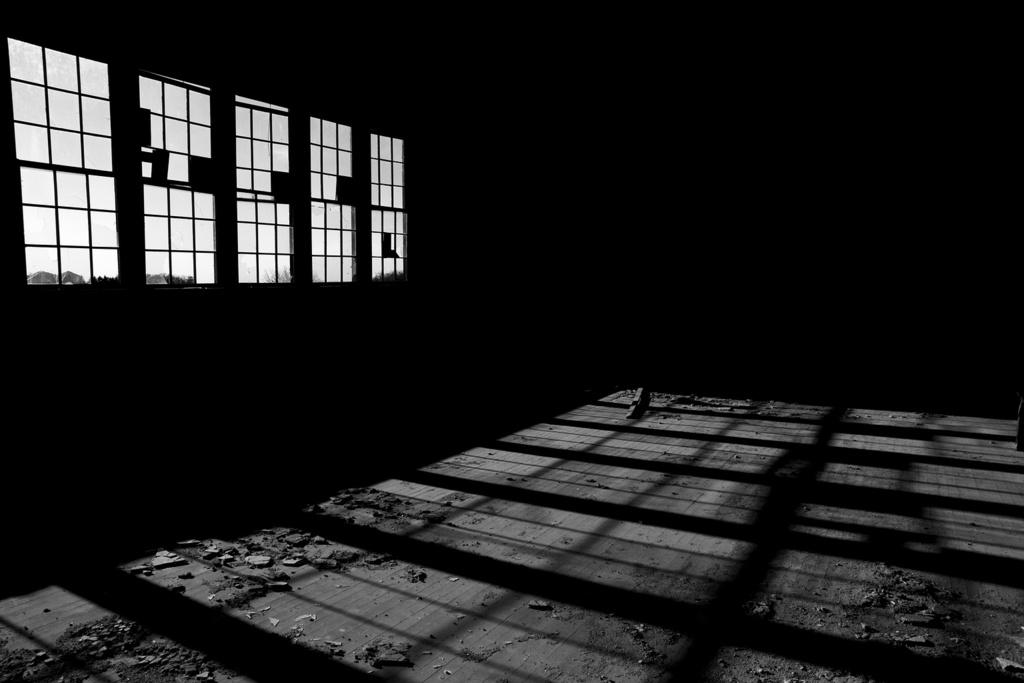What is located in the center of the image on the ground? There are stones in the center of the image on the ground. What can be seen on the left side of the image? There are windows on the left side of the image. What type of organization is depicted in the image? There is no organization depicted in the image; it features stones on the ground and windows on the left side. Can you tell me how many lakes are visible in the image? There are no lakes present in the image. 